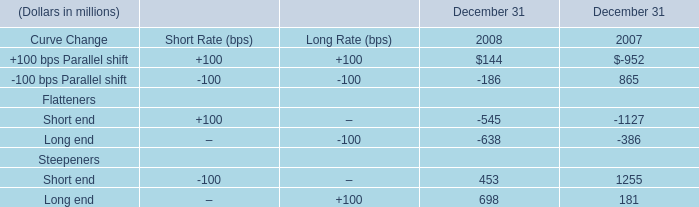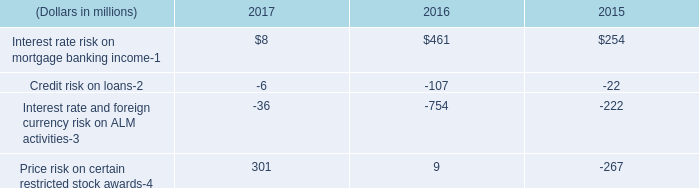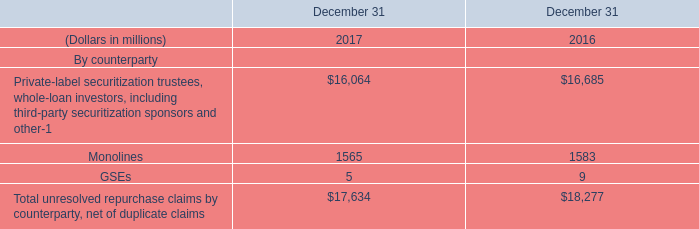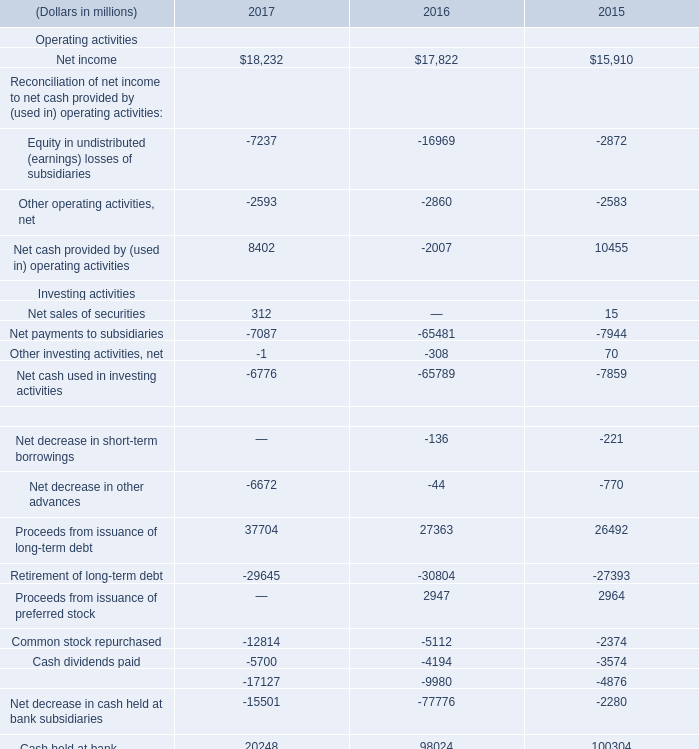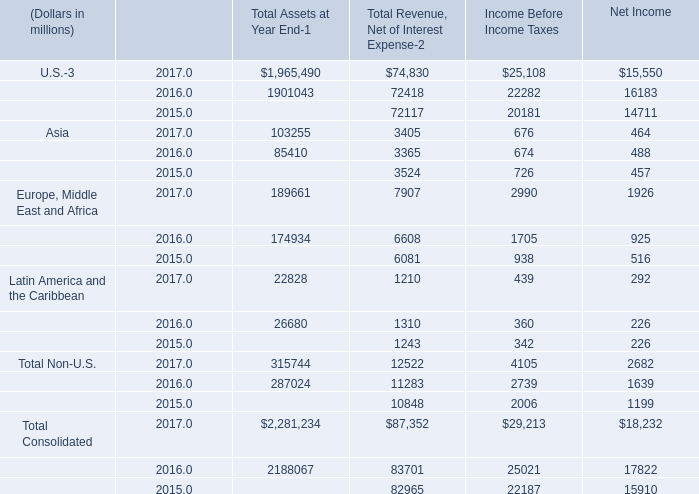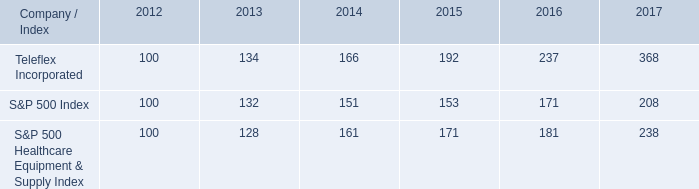what is roi of an investment in s&p 500 index in 2012 and sold in 2017? 
Computations: ((208 - 100) / 100)
Answer: 1.08. 